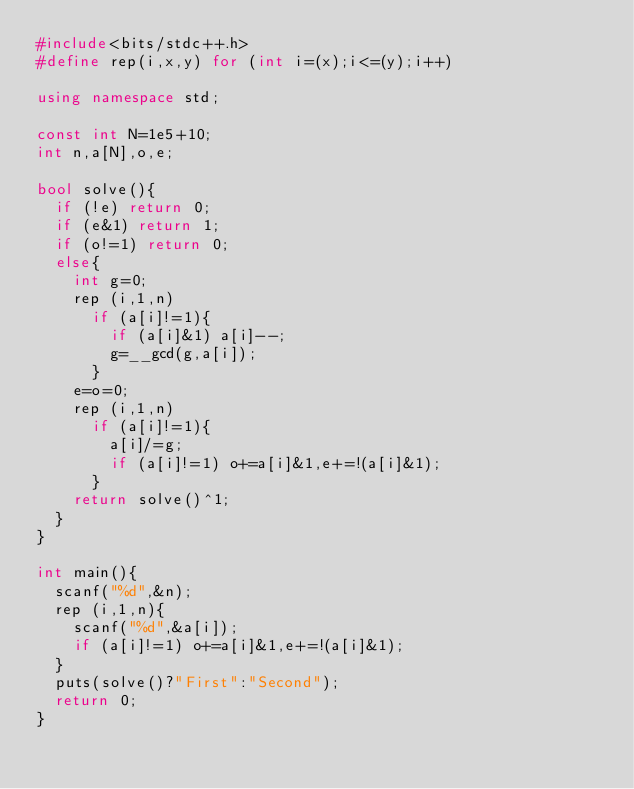Convert code to text. <code><loc_0><loc_0><loc_500><loc_500><_C++_>#include<bits/stdc++.h>
#define rep(i,x,y) for (int i=(x);i<=(y);i++)

using namespace std;

const int N=1e5+10;
int n,a[N],o,e;

bool solve(){
	if (!e) return 0;
	if (e&1) return 1;
	if (o!=1) return 0;
	else{
		int g=0;
		rep (i,1,n)
			if (a[i]!=1){
				if (a[i]&1) a[i]--;
				g=__gcd(g,a[i]);
			}
		e=o=0;
		rep (i,1,n)
			if (a[i]!=1){
				a[i]/=g;
				if (a[i]!=1) o+=a[i]&1,e+=!(a[i]&1);
			}
		return solve()^1;
	}
}

int main(){
	scanf("%d",&n);
	rep (i,1,n){
		scanf("%d",&a[i]);
		if (a[i]!=1) o+=a[i]&1,e+=!(a[i]&1);
	}
	puts(solve()?"First":"Second");
	return 0;
}</code> 